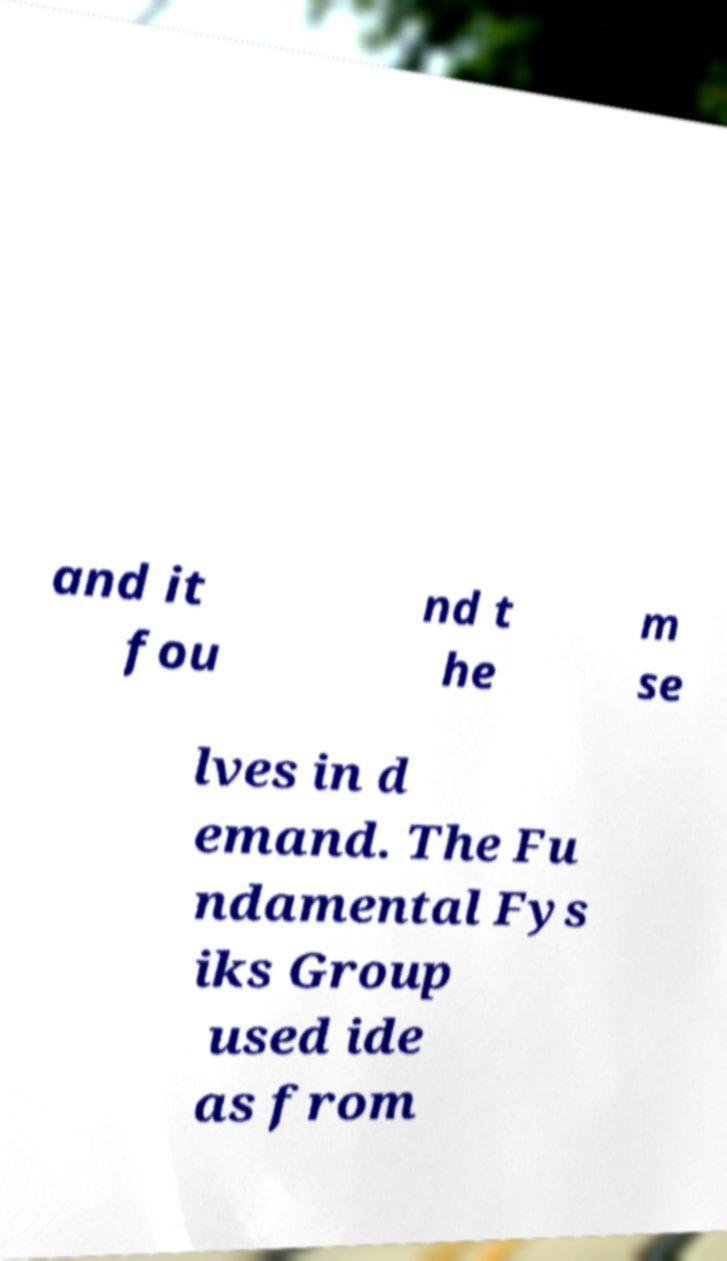Please read and relay the text visible in this image. What does it say? and it fou nd t he m se lves in d emand. The Fu ndamental Fys iks Group used ide as from 